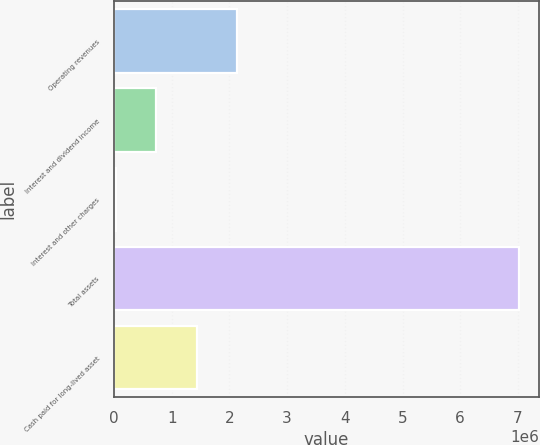Convert chart to OTSL. <chart><loc_0><loc_0><loc_500><loc_500><bar_chart><fcel>Operating revenues<fcel>Interest and dividend income<fcel>Interest and other charges<fcel>Total assets<fcel>Cash paid for long-lived asset<nl><fcel>2.12866e+06<fcel>732713<fcel>34738<fcel>7.01448e+06<fcel>1.43069e+06<nl></chart> 